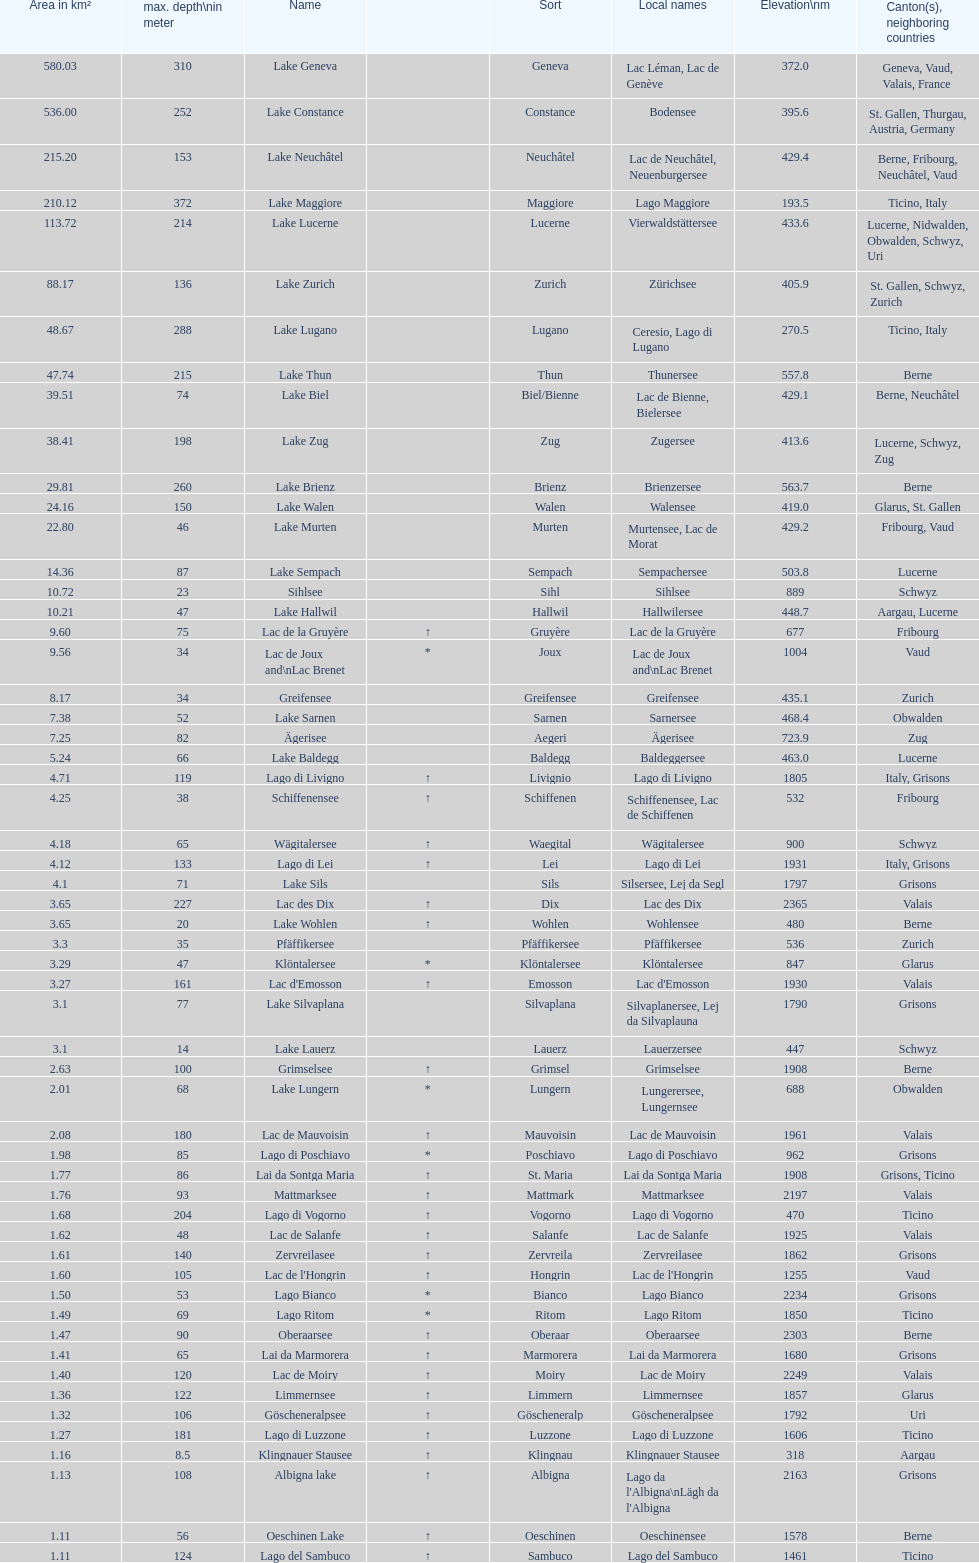What is the number of lakes that have an area less than 100 km squared? 51. 